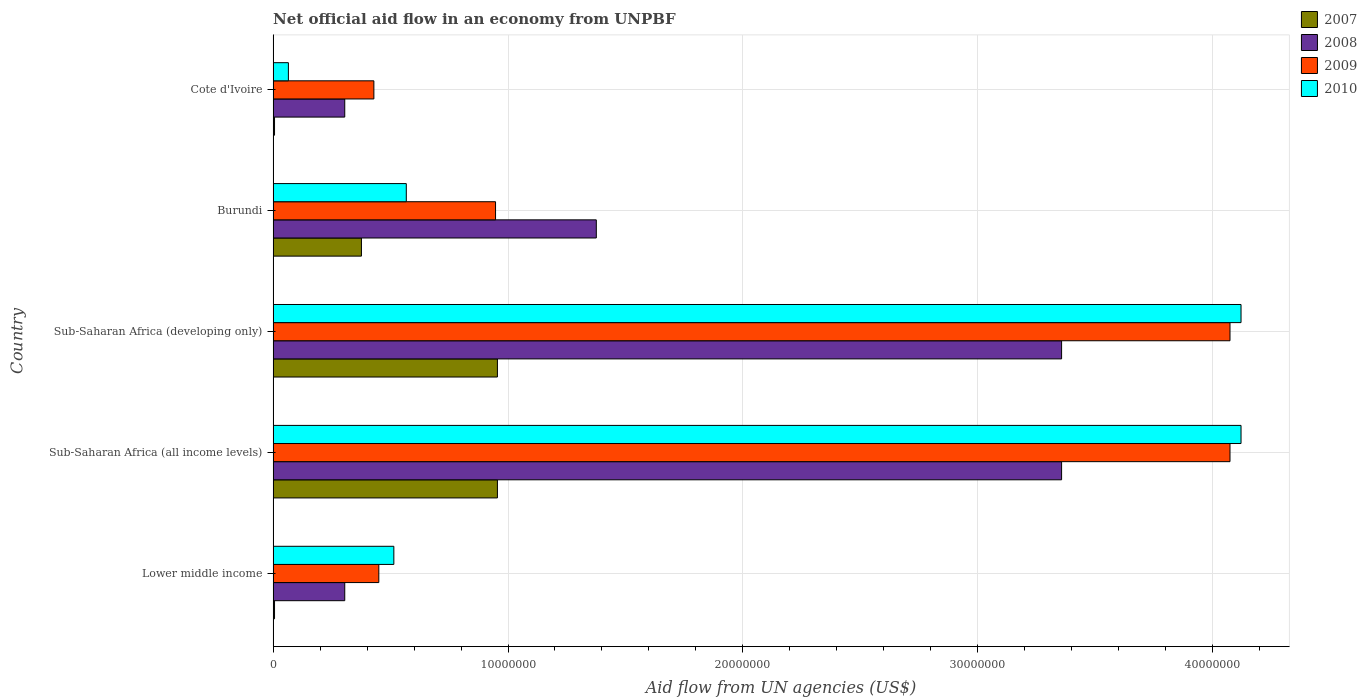How many different coloured bars are there?
Provide a succinct answer. 4. How many groups of bars are there?
Provide a succinct answer. 5. Are the number of bars per tick equal to the number of legend labels?
Keep it short and to the point. Yes. How many bars are there on the 5th tick from the bottom?
Give a very brief answer. 4. What is the label of the 3rd group of bars from the top?
Provide a short and direct response. Sub-Saharan Africa (developing only). What is the net official aid flow in 2008 in Lower middle income?
Your response must be concise. 3.05e+06. Across all countries, what is the maximum net official aid flow in 2007?
Offer a very short reply. 9.55e+06. Across all countries, what is the minimum net official aid flow in 2010?
Give a very brief answer. 6.50e+05. In which country was the net official aid flow in 2010 maximum?
Provide a short and direct response. Sub-Saharan Africa (all income levels). In which country was the net official aid flow in 2008 minimum?
Keep it short and to the point. Lower middle income. What is the total net official aid flow in 2007 in the graph?
Ensure brevity in your answer.  2.30e+07. What is the difference between the net official aid flow in 2010 in Burundi and that in Sub-Saharan Africa (developing only)?
Provide a succinct answer. -3.55e+07. What is the difference between the net official aid flow in 2008 in Sub-Saharan Africa (developing only) and the net official aid flow in 2007 in Lower middle income?
Offer a terse response. 3.35e+07. What is the average net official aid flow in 2008 per country?
Your response must be concise. 1.74e+07. What is the difference between the net official aid flow in 2009 and net official aid flow in 2010 in Sub-Saharan Africa (developing only)?
Give a very brief answer. -4.70e+05. In how many countries, is the net official aid flow in 2007 greater than 22000000 US$?
Make the answer very short. 0. Is the net official aid flow in 2007 in Cote d'Ivoire less than that in Sub-Saharan Africa (developing only)?
Ensure brevity in your answer.  Yes. What is the difference between the highest and the second highest net official aid flow in 2010?
Make the answer very short. 0. What is the difference between the highest and the lowest net official aid flow in 2007?
Your answer should be very brief. 9.49e+06. What does the 2nd bar from the bottom in Cote d'Ivoire represents?
Offer a terse response. 2008. How many countries are there in the graph?
Your answer should be compact. 5. What is the difference between two consecutive major ticks on the X-axis?
Your answer should be very brief. 1.00e+07. Are the values on the major ticks of X-axis written in scientific E-notation?
Your answer should be compact. No. Where does the legend appear in the graph?
Your answer should be compact. Top right. What is the title of the graph?
Provide a short and direct response. Net official aid flow in an economy from UNPBF. What is the label or title of the X-axis?
Provide a succinct answer. Aid flow from UN agencies (US$). What is the label or title of the Y-axis?
Offer a terse response. Country. What is the Aid flow from UN agencies (US$) in 2007 in Lower middle income?
Offer a very short reply. 6.00e+04. What is the Aid flow from UN agencies (US$) in 2008 in Lower middle income?
Provide a short and direct response. 3.05e+06. What is the Aid flow from UN agencies (US$) of 2009 in Lower middle income?
Provide a short and direct response. 4.50e+06. What is the Aid flow from UN agencies (US$) of 2010 in Lower middle income?
Give a very brief answer. 5.14e+06. What is the Aid flow from UN agencies (US$) in 2007 in Sub-Saharan Africa (all income levels)?
Make the answer very short. 9.55e+06. What is the Aid flow from UN agencies (US$) of 2008 in Sub-Saharan Africa (all income levels)?
Offer a very short reply. 3.36e+07. What is the Aid flow from UN agencies (US$) of 2009 in Sub-Saharan Africa (all income levels)?
Offer a very short reply. 4.07e+07. What is the Aid flow from UN agencies (US$) of 2010 in Sub-Saharan Africa (all income levels)?
Offer a terse response. 4.12e+07. What is the Aid flow from UN agencies (US$) of 2007 in Sub-Saharan Africa (developing only)?
Your response must be concise. 9.55e+06. What is the Aid flow from UN agencies (US$) in 2008 in Sub-Saharan Africa (developing only)?
Give a very brief answer. 3.36e+07. What is the Aid flow from UN agencies (US$) in 2009 in Sub-Saharan Africa (developing only)?
Make the answer very short. 4.07e+07. What is the Aid flow from UN agencies (US$) in 2010 in Sub-Saharan Africa (developing only)?
Your answer should be very brief. 4.12e+07. What is the Aid flow from UN agencies (US$) of 2007 in Burundi?
Provide a succinct answer. 3.76e+06. What is the Aid flow from UN agencies (US$) in 2008 in Burundi?
Offer a terse response. 1.38e+07. What is the Aid flow from UN agencies (US$) in 2009 in Burundi?
Make the answer very short. 9.47e+06. What is the Aid flow from UN agencies (US$) of 2010 in Burundi?
Provide a short and direct response. 5.67e+06. What is the Aid flow from UN agencies (US$) in 2008 in Cote d'Ivoire?
Make the answer very short. 3.05e+06. What is the Aid flow from UN agencies (US$) in 2009 in Cote d'Ivoire?
Provide a succinct answer. 4.29e+06. What is the Aid flow from UN agencies (US$) in 2010 in Cote d'Ivoire?
Give a very brief answer. 6.50e+05. Across all countries, what is the maximum Aid flow from UN agencies (US$) in 2007?
Keep it short and to the point. 9.55e+06. Across all countries, what is the maximum Aid flow from UN agencies (US$) in 2008?
Offer a terse response. 3.36e+07. Across all countries, what is the maximum Aid flow from UN agencies (US$) in 2009?
Provide a short and direct response. 4.07e+07. Across all countries, what is the maximum Aid flow from UN agencies (US$) of 2010?
Your answer should be compact. 4.12e+07. Across all countries, what is the minimum Aid flow from UN agencies (US$) in 2008?
Offer a very short reply. 3.05e+06. Across all countries, what is the minimum Aid flow from UN agencies (US$) in 2009?
Offer a very short reply. 4.29e+06. Across all countries, what is the minimum Aid flow from UN agencies (US$) in 2010?
Your answer should be compact. 6.50e+05. What is the total Aid flow from UN agencies (US$) of 2007 in the graph?
Provide a short and direct response. 2.30e+07. What is the total Aid flow from UN agencies (US$) in 2008 in the graph?
Offer a very short reply. 8.70e+07. What is the total Aid flow from UN agencies (US$) of 2009 in the graph?
Provide a short and direct response. 9.97e+07. What is the total Aid flow from UN agencies (US$) of 2010 in the graph?
Offer a terse response. 9.39e+07. What is the difference between the Aid flow from UN agencies (US$) in 2007 in Lower middle income and that in Sub-Saharan Africa (all income levels)?
Give a very brief answer. -9.49e+06. What is the difference between the Aid flow from UN agencies (US$) in 2008 in Lower middle income and that in Sub-Saharan Africa (all income levels)?
Give a very brief answer. -3.05e+07. What is the difference between the Aid flow from UN agencies (US$) of 2009 in Lower middle income and that in Sub-Saharan Africa (all income levels)?
Make the answer very short. -3.62e+07. What is the difference between the Aid flow from UN agencies (US$) of 2010 in Lower middle income and that in Sub-Saharan Africa (all income levels)?
Your response must be concise. -3.61e+07. What is the difference between the Aid flow from UN agencies (US$) in 2007 in Lower middle income and that in Sub-Saharan Africa (developing only)?
Offer a terse response. -9.49e+06. What is the difference between the Aid flow from UN agencies (US$) in 2008 in Lower middle income and that in Sub-Saharan Africa (developing only)?
Offer a terse response. -3.05e+07. What is the difference between the Aid flow from UN agencies (US$) of 2009 in Lower middle income and that in Sub-Saharan Africa (developing only)?
Ensure brevity in your answer.  -3.62e+07. What is the difference between the Aid flow from UN agencies (US$) of 2010 in Lower middle income and that in Sub-Saharan Africa (developing only)?
Provide a short and direct response. -3.61e+07. What is the difference between the Aid flow from UN agencies (US$) of 2007 in Lower middle income and that in Burundi?
Your answer should be compact. -3.70e+06. What is the difference between the Aid flow from UN agencies (US$) in 2008 in Lower middle income and that in Burundi?
Make the answer very short. -1.07e+07. What is the difference between the Aid flow from UN agencies (US$) of 2009 in Lower middle income and that in Burundi?
Provide a short and direct response. -4.97e+06. What is the difference between the Aid flow from UN agencies (US$) in 2010 in Lower middle income and that in Burundi?
Give a very brief answer. -5.30e+05. What is the difference between the Aid flow from UN agencies (US$) of 2007 in Lower middle income and that in Cote d'Ivoire?
Your answer should be very brief. 0. What is the difference between the Aid flow from UN agencies (US$) in 2008 in Lower middle income and that in Cote d'Ivoire?
Your answer should be very brief. 0. What is the difference between the Aid flow from UN agencies (US$) of 2010 in Lower middle income and that in Cote d'Ivoire?
Provide a succinct answer. 4.49e+06. What is the difference between the Aid flow from UN agencies (US$) of 2007 in Sub-Saharan Africa (all income levels) and that in Burundi?
Give a very brief answer. 5.79e+06. What is the difference between the Aid flow from UN agencies (US$) in 2008 in Sub-Saharan Africa (all income levels) and that in Burundi?
Your answer should be compact. 1.98e+07. What is the difference between the Aid flow from UN agencies (US$) of 2009 in Sub-Saharan Africa (all income levels) and that in Burundi?
Make the answer very short. 3.13e+07. What is the difference between the Aid flow from UN agencies (US$) in 2010 in Sub-Saharan Africa (all income levels) and that in Burundi?
Make the answer very short. 3.55e+07. What is the difference between the Aid flow from UN agencies (US$) of 2007 in Sub-Saharan Africa (all income levels) and that in Cote d'Ivoire?
Offer a very short reply. 9.49e+06. What is the difference between the Aid flow from UN agencies (US$) of 2008 in Sub-Saharan Africa (all income levels) and that in Cote d'Ivoire?
Provide a succinct answer. 3.05e+07. What is the difference between the Aid flow from UN agencies (US$) of 2009 in Sub-Saharan Africa (all income levels) and that in Cote d'Ivoire?
Give a very brief answer. 3.64e+07. What is the difference between the Aid flow from UN agencies (US$) of 2010 in Sub-Saharan Africa (all income levels) and that in Cote d'Ivoire?
Offer a terse response. 4.06e+07. What is the difference between the Aid flow from UN agencies (US$) of 2007 in Sub-Saharan Africa (developing only) and that in Burundi?
Offer a terse response. 5.79e+06. What is the difference between the Aid flow from UN agencies (US$) in 2008 in Sub-Saharan Africa (developing only) and that in Burundi?
Keep it short and to the point. 1.98e+07. What is the difference between the Aid flow from UN agencies (US$) of 2009 in Sub-Saharan Africa (developing only) and that in Burundi?
Keep it short and to the point. 3.13e+07. What is the difference between the Aid flow from UN agencies (US$) in 2010 in Sub-Saharan Africa (developing only) and that in Burundi?
Ensure brevity in your answer.  3.55e+07. What is the difference between the Aid flow from UN agencies (US$) in 2007 in Sub-Saharan Africa (developing only) and that in Cote d'Ivoire?
Keep it short and to the point. 9.49e+06. What is the difference between the Aid flow from UN agencies (US$) of 2008 in Sub-Saharan Africa (developing only) and that in Cote d'Ivoire?
Keep it short and to the point. 3.05e+07. What is the difference between the Aid flow from UN agencies (US$) of 2009 in Sub-Saharan Africa (developing only) and that in Cote d'Ivoire?
Make the answer very short. 3.64e+07. What is the difference between the Aid flow from UN agencies (US$) in 2010 in Sub-Saharan Africa (developing only) and that in Cote d'Ivoire?
Keep it short and to the point. 4.06e+07. What is the difference between the Aid flow from UN agencies (US$) of 2007 in Burundi and that in Cote d'Ivoire?
Your response must be concise. 3.70e+06. What is the difference between the Aid flow from UN agencies (US$) in 2008 in Burundi and that in Cote d'Ivoire?
Give a very brief answer. 1.07e+07. What is the difference between the Aid flow from UN agencies (US$) of 2009 in Burundi and that in Cote d'Ivoire?
Offer a terse response. 5.18e+06. What is the difference between the Aid flow from UN agencies (US$) of 2010 in Burundi and that in Cote d'Ivoire?
Make the answer very short. 5.02e+06. What is the difference between the Aid flow from UN agencies (US$) of 2007 in Lower middle income and the Aid flow from UN agencies (US$) of 2008 in Sub-Saharan Africa (all income levels)?
Keep it short and to the point. -3.35e+07. What is the difference between the Aid flow from UN agencies (US$) of 2007 in Lower middle income and the Aid flow from UN agencies (US$) of 2009 in Sub-Saharan Africa (all income levels)?
Ensure brevity in your answer.  -4.07e+07. What is the difference between the Aid flow from UN agencies (US$) of 2007 in Lower middle income and the Aid flow from UN agencies (US$) of 2010 in Sub-Saharan Africa (all income levels)?
Your answer should be very brief. -4.12e+07. What is the difference between the Aid flow from UN agencies (US$) of 2008 in Lower middle income and the Aid flow from UN agencies (US$) of 2009 in Sub-Saharan Africa (all income levels)?
Your answer should be very brief. -3.77e+07. What is the difference between the Aid flow from UN agencies (US$) in 2008 in Lower middle income and the Aid flow from UN agencies (US$) in 2010 in Sub-Saharan Africa (all income levels)?
Your answer should be very brief. -3.82e+07. What is the difference between the Aid flow from UN agencies (US$) in 2009 in Lower middle income and the Aid flow from UN agencies (US$) in 2010 in Sub-Saharan Africa (all income levels)?
Offer a terse response. -3.67e+07. What is the difference between the Aid flow from UN agencies (US$) of 2007 in Lower middle income and the Aid flow from UN agencies (US$) of 2008 in Sub-Saharan Africa (developing only)?
Provide a succinct answer. -3.35e+07. What is the difference between the Aid flow from UN agencies (US$) in 2007 in Lower middle income and the Aid flow from UN agencies (US$) in 2009 in Sub-Saharan Africa (developing only)?
Give a very brief answer. -4.07e+07. What is the difference between the Aid flow from UN agencies (US$) in 2007 in Lower middle income and the Aid flow from UN agencies (US$) in 2010 in Sub-Saharan Africa (developing only)?
Make the answer very short. -4.12e+07. What is the difference between the Aid flow from UN agencies (US$) of 2008 in Lower middle income and the Aid flow from UN agencies (US$) of 2009 in Sub-Saharan Africa (developing only)?
Your response must be concise. -3.77e+07. What is the difference between the Aid flow from UN agencies (US$) in 2008 in Lower middle income and the Aid flow from UN agencies (US$) in 2010 in Sub-Saharan Africa (developing only)?
Ensure brevity in your answer.  -3.82e+07. What is the difference between the Aid flow from UN agencies (US$) in 2009 in Lower middle income and the Aid flow from UN agencies (US$) in 2010 in Sub-Saharan Africa (developing only)?
Your answer should be compact. -3.67e+07. What is the difference between the Aid flow from UN agencies (US$) of 2007 in Lower middle income and the Aid flow from UN agencies (US$) of 2008 in Burundi?
Your answer should be very brief. -1.37e+07. What is the difference between the Aid flow from UN agencies (US$) of 2007 in Lower middle income and the Aid flow from UN agencies (US$) of 2009 in Burundi?
Offer a very short reply. -9.41e+06. What is the difference between the Aid flow from UN agencies (US$) in 2007 in Lower middle income and the Aid flow from UN agencies (US$) in 2010 in Burundi?
Offer a terse response. -5.61e+06. What is the difference between the Aid flow from UN agencies (US$) in 2008 in Lower middle income and the Aid flow from UN agencies (US$) in 2009 in Burundi?
Offer a terse response. -6.42e+06. What is the difference between the Aid flow from UN agencies (US$) of 2008 in Lower middle income and the Aid flow from UN agencies (US$) of 2010 in Burundi?
Make the answer very short. -2.62e+06. What is the difference between the Aid flow from UN agencies (US$) in 2009 in Lower middle income and the Aid flow from UN agencies (US$) in 2010 in Burundi?
Ensure brevity in your answer.  -1.17e+06. What is the difference between the Aid flow from UN agencies (US$) in 2007 in Lower middle income and the Aid flow from UN agencies (US$) in 2008 in Cote d'Ivoire?
Keep it short and to the point. -2.99e+06. What is the difference between the Aid flow from UN agencies (US$) in 2007 in Lower middle income and the Aid flow from UN agencies (US$) in 2009 in Cote d'Ivoire?
Provide a succinct answer. -4.23e+06. What is the difference between the Aid flow from UN agencies (US$) in 2007 in Lower middle income and the Aid flow from UN agencies (US$) in 2010 in Cote d'Ivoire?
Make the answer very short. -5.90e+05. What is the difference between the Aid flow from UN agencies (US$) of 2008 in Lower middle income and the Aid flow from UN agencies (US$) of 2009 in Cote d'Ivoire?
Offer a terse response. -1.24e+06. What is the difference between the Aid flow from UN agencies (US$) of 2008 in Lower middle income and the Aid flow from UN agencies (US$) of 2010 in Cote d'Ivoire?
Give a very brief answer. 2.40e+06. What is the difference between the Aid flow from UN agencies (US$) in 2009 in Lower middle income and the Aid flow from UN agencies (US$) in 2010 in Cote d'Ivoire?
Offer a terse response. 3.85e+06. What is the difference between the Aid flow from UN agencies (US$) in 2007 in Sub-Saharan Africa (all income levels) and the Aid flow from UN agencies (US$) in 2008 in Sub-Saharan Africa (developing only)?
Your answer should be very brief. -2.40e+07. What is the difference between the Aid flow from UN agencies (US$) in 2007 in Sub-Saharan Africa (all income levels) and the Aid flow from UN agencies (US$) in 2009 in Sub-Saharan Africa (developing only)?
Ensure brevity in your answer.  -3.12e+07. What is the difference between the Aid flow from UN agencies (US$) of 2007 in Sub-Saharan Africa (all income levels) and the Aid flow from UN agencies (US$) of 2010 in Sub-Saharan Africa (developing only)?
Your answer should be compact. -3.17e+07. What is the difference between the Aid flow from UN agencies (US$) in 2008 in Sub-Saharan Africa (all income levels) and the Aid flow from UN agencies (US$) in 2009 in Sub-Saharan Africa (developing only)?
Your response must be concise. -7.17e+06. What is the difference between the Aid flow from UN agencies (US$) of 2008 in Sub-Saharan Africa (all income levels) and the Aid flow from UN agencies (US$) of 2010 in Sub-Saharan Africa (developing only)?
Give a very brief answer. -7.64e+06. What is the difference between the Aid flow from UN agencies (US$) in 2009 in Sub-Saharan Africa (all income levels) and the Aid flow from UN agencies (US$) in 2010 in Sub-Saharan Africa (developing only)?
Make the answer very short. -4.70e+05. What is the difference between the Aid flow from UN agencies (US$) of 2007 in Sub-Saharan Africa (all income levels) and the Aid flow from UN agencies (US$) of 2008 in Burundi?
Provide a succinct answer. -4.21e+06. What is the difference between the Aid flow from UN agencies (US$) of 2007 in Sub-Saharan Africa (all income levels) and the Aid flow from UN agencies (US$) of 2010 in Burundi?
Make the answer very short. 3.88e+06. What is the difference between the Aid flow from UN agencies (US$) in 2008 in Sub-Saharan Africa (all income levels) and the Aid flow from UN agencies (US$) in 2009 in Burundi?
Your answer should be very brief. 2.41e+07. What is the difference between the Aid flow from UN agencies (US$) of 2008 in Sub-Saharan Africa (all income levels) and the Aid flow from UN agencies (US$) of 2010 in Burundi?
Keep it short and to the point. 2.79e+07. What is the difference between the Aid flow from UN agencies (US$) in 2009 in Sub-Saharan Africa (all income levels) and the Aid flow from UN agencies (US$) in 2010 in Burundi?
Ensure brevity in your answer.  3.51e+07. What is the difference between the Aid flow from UN agencies (US$) in 2007 in Sub-Saharan Africa (all income levels) and the Aid flow from UN agencies (US$) in 2008 in Cote d'Ivoire?
Provide a short and direct response. 6.50e+06. What is the difference between the Aid flow from UN agencies (US$) of 2007 in Sub-Saharan Africa (all income levels) and the Aid flow from UN agencies (US$) of 2009 in Cote d'Ivoire?
Keep it short and to the point. 5.26e+06. What is the difference between the Aid flow from UN agencies (US$) in 2007 in Sub-Saharan Africa (all income levels) and the Aid flow from UN agencies (US$) in 2010 in Cote d'Ivoire?
Offer a very short reply. 8.90e+06. What is the difference between the Aid flow from UN agencies (US$) of 2008 in Sub-Saharan Africa (all income levels) and the Aid flow from UN agencies (US$) of 2009 in Cote d'Ivoire?
Provide a short and direct response. 2.93e+07. What is the difference between the Aid flow from UN agencies (US$) in 2008 in Sub-Saharan Africa (all income levels) and the Aid flow from UN agencies (US$) in 2010 in Cote d'Ivoire?
Your answer should be very brief. 3.29e+07. What is the difference between the Aid flow from UN agencies (US$) in 2009 in Sub-Saharan Africa (all income levels) and the Aid flow from UN agencies (US$) in 2010 in Cote d'Ivoire?
Your answer should be very brief. 4.01e+07. What is the difference between the Aid flow from UN agencies (US$) in 2007 in Sub-Saharan Africa (developing only) and the Aid flow from UN agencies (US$) in 2008 in Burundi?
Ensure brevity in your answer.  -4.21e+06. What is the difference between the Aid flow from UN agencies (US$) of 2007 in Sub-Saharan Africa (developing only) and the Aid flow from UN agencies (US$) of 2010 in Burundi?
Ensure brevity in your answer.  3.88e+06. What is the difference between the Aid flow from UN agencies (US$) of 2008 in Sub-Saharan Africa (developing only) and the Aid flow from UN agencies (US$) of 2009 in Burundi?
Your answer should be compact. 2.41e+07. What is the difference between the Aid flow from UN agencies (US$) of 2008 in Sub-Saharan Africa (developing only) and the Aid flow from UN agencies (US$) of 2010 in Burundi?
Provide a short and direct response. 2.79e+07. What is the difference between the Aid flow from UN agencies (US$) of 2009 in Sub-Saharan Africa (developing only) and the Aid flow from UN agencies (US$) of 2010 in Burundi?
Provide a short and direct response. 3.51e+07. What is the difference between the Aid flow from UN agencies (US$) in 2007 in Sub-Saharan Africa (developing only) and the Aid flow from UN agencies (US$) in 2008 in Cote d'Ivoire?
Offer a very short reply. 6.50e+06. What is the difference between the Aid flow from UN agencies (US$) in 2007 in Sub-Saharan Africa (developing only) and the Aid flow from UN agencies (US$) in 2009 in Cote d'Ivoire?
Offer a terse response. 5.26e+06. What is the difference between the Aid flow from UN agencies (US$) in 2007 in Sub-Saharan Africa (developing only) and the Aid flow from UN agencies (US$) in 2010 in Cote d'Ivoire?
Offer a very short reply. 8.90e+06. What is the difference between the Aid flow from UN agencies (US$) of 2008 in Sub-Saharan Africa (developing only) and the Aid flow from UN agencies (US$) of 2009 in Cote d'Ivoire?
Offer a very short reply. 2.93e+07. What is the difference between the Aid flow from UN agencies (US$) of 2008 in Sub-Saharan Africa (developing only) and the Aid flow from UN agencies (US$) of 2010 in Cote d'Ivoire?
Your answer should be very brief. 3.29e+07. What is the difference between the Aid flow from UN agencies (US$) of 2009 in Sub-Saharan Africa (developing only) and the Aid flow from UN agencies (US$) of 2010 in Cote d'Ivoire?
Ensure brevity in your answer.  4.01e+07. What is the difference between the Aid flow from UN agencies (US$) in 2007 in Burundi and the Aid flow from UN agencies (US$) in 2008 in Cote d'Ivoire?
Offer a terse response. 7.10e+05. What is the difference between the Aid flow from UN agencies (US$) in 2007 in Burundi and the Aid flow from UN agencies (US$) in 2009 in Cote d'Ivoire?
Keep it short and to the point. -5.30e+05. What is the difference between the Aid flow from UN agencies (US$) in 2007 in Burundi and the Aid flow from UN agencies (US$) in 2010 in Cote d'Ivoire?
Ensure brevity in your answer.  3.11e+06. What is the difference between the Aid flow from UN agencies (US$) of 2008 in Burundi and the Aid flow from UN agencies (US$) of 2009 in Cote d'Ivoire?
Offer a very short reply. 9.47e+06. What is the difference between the Aid flow from UN agencies (US$) in 2008 in Burundi and the Aid flow from UN agencies (US$) in 2010 in Cote d'Ivoire?
Your answer should be compact. 1.31e+07. What is the difference between the Aid flow from UN agencies (US$) of 2009 in Burundi and the Aid flow from UN agencies (US$) of 2010 in Cote d'Ivoire?
Your answer should be very brief. 8.82e+06. What is the average Aid flow from UN agencies (US$) of 2007 per country?
Your answer should be compact. 4.60e+06. What is the average Aid flow from UN agencies (US$) of 2008 per country?
Provide a succinct answer. 1.74e+07. What is the average Aid flow from UN agencies (US$) of 2009 per country?
Your response must be concise. 1.99e+07. What is the average Aid flow from UN agencies (US$) in 2010 per country?
Give a very brief answer. 1.88e+07. What is the difference between the Aid flow from UN agencies (US$) of 2007 and Aid flow from UN agencies (US$) of 2008 in Lower middle income?
Keep it short and to the point. -2.99e+06. What is the difference between the Aid flow from UN agencies (US$) in 2007 and Aid flow from UN agencies (US$) in 2009 in Lower middle income?
Offer a very short reply. -4.44e+06. What is the difference between the Aid flow from UN agencies (US$) in 2007 and Aid flow from UN agencies (US$) in 2010 in Lower middle income?
Your response must be concise. -5.08e+06. What is the difference between the Aid flow from UN agencies (US$) in 2008 and Aid flow from UN agencies (US$) in 2009 in Lower middle income?
Your answer should be very brief. -1.45e+06. What is the difference between the Aid flow from UN agencies (US$) of 2008 and Aid flow from UN agencies (US$) of 2010 in Lower middle income?
Ensure brevity in your answer.  -2.09e+06. What is the difference between the Aid flow from UN agencies (US$) of 2009 and Aid flow from UN agencies (US$) of 2010 in Lower middle income?
Offer a terse response. -6.40e+05. What is the difference between the Aid flow from UN agencies (US$) of 2007 and Aid flow from UN agencies (US$) of 2008 in Sub-Saharan Africa (all income levels)?
Make the answer very short. -2.40e+07. What is the difference between the Aid flow from UN agencies (US$) of 2007 and Aid flow from UN agencies (US$) of 2009 in Sub-Saharan Africa (all income levels)?
Ensure brevity in your answer.  -3.12e+07. What is the difference between the Aid flow from UN agencies (US$) in 2007 and Aid flow from UN agencies (US$) in 2010 in Sub-Saharan Africa (all income levels)?
Your answer should be compact. -3.17e+07. What is the difference between the Aid flow from UN agencies (US$) in 2008 and Aid flow from UN agencies (US$) in 2009 in Sub-Saharan Africa (all income levels)?
Offer a terse response. -7.17e+06. What is the difference between the Aid flow from UN agencies (US$) of 2008 and Aid flow from UN agencies (US$) of 2010 in Sub-Saharan Africa (all income levels)?
Offer a terse response. -7.64e+06. What is the difference between the Aid flow from UN agencies (US$) in 2009 and Aid flow from UN agencies (US$) in 2010 in Sub-Saharan Africa (all income levels)?
Your response must be concise. -4.70e+05. What is the difference between the Aid flow from UN agencies (US$) of 2007 and Aid flow from UN agencies (US$) of 2008 in Sub-Saharan Africa (developing only)?
Give a very brief answer. -2.40e+07. What is the difference between the Aid flow from UN agencies (US$) of 2007 and Aid flow from UN agencies (US$) of 2009 in Sub-Saharan Africa (developing only)?
Your answer should be compact. -3.12e+07. What is the difference between the Aid flow from UN agencies (US$) of 2007 and Aid flow from UN agencies (US$) of 2010 in Sub-Saharan Africa (developing only)?
Make the answer very short. -3.17e+07. What is the difference between the Aid flow from UN agencies (US$) in 2008 and Aid flow from UN agencies (US$) in 2009 in Sub-Saharan Africa (developing only)?
Offer a very short reply. -7.17e+06. What is the difference between the Aid flow from UN agencies (US$) in 2008 and Aid flow from UN agencies (US$) in 2010 in Sub-Saharan Africa (developing only)?
Ensure brevity in your answer.  -7.64e+06. What is the difference between the Aid flow from UN agencies (US$) in 2009 and Aid flow from UN agencies (US$) in 2010 in Sub-Saharan Africa (developing only)?
Your answer should be compact. -4.70e+05. What is the difference between the Aid flow from UN agencies (US$) in 2007 and Aid flow from UN agencies (US$) in 2008 in Burundi?
Provide a succinct answer. -1.00e+07. What is the difference between the Aid flow from UN agencies (US$) of 2007 and Aid flow from UN agencies (US$) of 2009 in Burundi?
Provide a short and direct response. -5.71e+06. What is the difference between the Aid flow from UN agencies (US$) of 2007 and Aid flow from UN agencies (US$) of 2010 in Burundi?
Your answer should be compact. -1.91e+06. What is the difference between the Aid flow from UN agencies (US$) in 2008 and Aid flow from UN agencies (US$) in 2009 in Burundi?
Provide a short and direct response. 4.29e+06. What is the difference between the Aid flow from UN agencies (US$) in 2008 and Aid flow from UN agencies (US$) in 2010 in Burundi?
Keep it short and to the point. 8.09e+06. What is the difference between the Aid flow from UN agencies (US$) in 2009 and Aid flow from UN agencies (US$) in 2010 in Burundi?
Give a very brief answer. 3.80e+06. What is the difference between the Aid flow from UN agencies (US$) in 2007 and Aid flow from UN agencies (US$) in 2008 in Cote d'Ivoire?
Ensure brevity in your answer.  -2.99e+06. What is the difference between the Aid flow from UN agencies (US$) of 2007 and Aid flow from UN agencies (US$) of 2009 in Cote d'Ivoire?
Make the answer very short. -4.23e+06. What is the difference between the Aid flow from UN agencies (US$) of 2007 and Aid flow from UN agencies (US$) of 2010 in Cote d'Ivoire?
Provide a short and direct response. -5.90e+05. What is the difference between the Aid flow from UN agencies (US$) in 2008 and Aid flow from UN agencies (US$) in 2009 in Cote d'Ivoire?
Offer a terse response. -1.24e+06. What is the difference between the Aid flow from UN agencies (US$) in 2008 and Aid flow from UN agencies (US$) in 2010 in Cote d'Ivoire?
Ensure brevity in your answer.  2.40e+06. What is the difference between the Aid flow from UN agencies (US$) in 2009 and Aid flow from UN agencies (US$) in 2010 in Cote d'Ivoire?
Keep it short and to the point. 3.64e+06. What is the ratio of the Aid flow from UN agencies (US$) in 2007 in Lower middle income to that in Sub-Saharan Africa (all income levels)?
Ensure brevity in your answer.  0.01. What is the ratio of the Aid flow from UN agencies (US$) in 2008 in Lower middle income to that in Sub-Saharan Africa (all income levels)?
Your response must be concise. 0.09. What is the ratio of the Aid flow from UN agencies (US$) of 2009 in Lower middle income to that in Sub-Saharan Africa (all income levels)?
Your answer should be very brief. 0.11. What is the ratio of the Aid flow from UN agencies (US$) of 2010 in Lower middle income to that in Sub-Saharan Africa (all income levels)?
Ensure brevity in your answer.  0.12. What is the ratio of the Aid flow from UN agencies (US$) of 2007 in Lower middle income to that in Sub-Saharan Africa (developing only)?
Ensure brevity in your answer.  0.01. What is the ratio of the Aid flow from UN agencies (US$) in 2008 in Lower middle income to that in Sub-Saharan Africa (developing only)?
Make the answer very short. 0.09. What is the ratio of the Aid flow from UN agencies (US$) of 2009 in Lower middle income to that in Sub-Saharan Africa (developing only)?
Your answer should be very brief. 0.11. What is the ratio of the Aid flow from UN agencies (US$) of 2010 in Lower middle income to that in Sub-Saharan Africa (developing only)?
Give a very brief answer. 0.12. What is the ratio of the Aid flow from UN agencies (US$) in 2007 in Lower middle income to that in Burundi?
Keep it short and to the point. 0.02. What is the ratio of the Aid flow from UN agencies (US$) of 2008 in Lower middle income to that in Burundi?
Your response must be concise. 0.22. What is the ratio of the Aid flow from UN agencies (US$) of 2009 in Lower middle income to that in Burundi?
Give a very brief answer. 0.48. What is the ratio of the Aid flow from UN agencies (US$) of 2010 in Lower middle income to that in Burundi?
Give a very brief answer. 0.91. What is the ratio of the Aid flow from UN agencies (US$) in 2008 in Lower middle income to that in Cote d'Ivoire?
Your response must be concise. 1. What is the ratio of the Aid flow from UN agencies (US$) in 2009 in Lower middle income to that in Cote d'Ivoire?
Make the answer very short. 1.05. What is the ratio of the Aid flow from UN agencies (US$) of 2010 in Lower middle income to that in Cote d'Ivoire?
Provide a succinct answer. 7.91. What is the ratio of the Aid flow from UN agencies (US$) of 2008 in Sub-Saharan Africa (all income levels) to that in Sub-Saharan Africa (developing only)?
Offer a terse response. 1. What is the ratio of the Aid flow from UN agencies (US$) of 2010 in Sub-Saharan Africa (all income levels) to that in Sub-Saharan Africa (developing only)?
Provide a succinct answer. 1. What is the ratio of the Aid flow from UN agencies (US$) in 2007 in Sub-Saharan Africa (all income levels) to that in Burundi?
Ensure brevity in your answer.  2.54. What is the ratio of the Aid flow from UN agencies (US$) in 2008 in Sub-Saharan Africa (all income levels) to that in Burundi?
Provide a short and direct response. 2.44. What is the ratio of the Aid flow from UN agencies (US$) in 2009 in Sub-Saharan Africa (all income levels) to that in Burundi?
Your answer should be compact. 4.3. What is the ratio of the Aid flow from UN agencies (US$) in 2010 in Sub-Saharan Africa (all income levels) to that in Burundi?
Offer a terse response. 7.27. What is the ratio of the Aid flow from UN agencies (US$) of 2007 in Sub-Saharan Africa (all income levels) to that in Cote d'Ivoire?
Give a very brief answer. 159.17. What is the ratio of the Aid flow from UN agencies (US$) in 2008 in Sub-Saharan Africa (all income levels) to that in Cote d'Ivoire?
Provide a succinct answer. 11.01. What is the ratio of the Aid flow from UN agencies (US$) in 2009 in Sub-Saharan Africa (all income levels) to that in Cote d'Ivoire?
Give a very brief answer. 9.5. What is the ratio of the Aid flow from UN agencies (US$) of 2010 in Sub-Saharan Africa (all income levels) to that in Cote d'Ivoire?
Offer a very short reply. 63.4. What is the ratio of the Aid flow from UN agencies (US$) in 2007 in Sub-Saharan Africa (developing only) to that in Burundi?
Ensure brevity in your answer.  2.54. What is the ratio of the Aid flow from UN agencies (US$) in 2008 in Sub-Saharan Africa (developing only) to that in Burundi?
Your answer should be very brief. 2.44. What is the ratio of the Aid flow from UN agencies (US$) in 2009 in Sub-Saharan Africa (developing only) to that in Burundi?
Your answer should be compact. 4.3. What is the ratio of the Aid flow from UN agencies (US$) in 2010 in Sub-Saharan Africa (developing only) to that in Burundi?
Your answer should be very brief. 7.27. What is the ratio of the Aid flow from UN agencies (US$) in 2007 in Sub-Saharan Africa (developing only) to that in Cote d'Ivoire?
Provide a short and direct response. 159.17. What is the ratio of the Aid flow from UN agencies (US$) of 2008 in Sub-Saharan Africa (developing only) to that in Cote d'Ivoire?
Your answer should be very brief. 11.01. What is the ratio of the Aid flow from UN agencies (US$) of 2009 in Sub-Saharan Africa (developing only) to that in Cote d'Ivoire?
Offer a terse response. 9.5. What is the ratio of the Aid flow from UN agencies (US$) of 2010 in Sub-Saharan Africa (developing only) to that in Cote d'Ivoire?
Provide a short and direct response. 63.4. What is the ratio of the Aid flow from UN agencies (US$) in 2007 in Burundi to that in Cote d'Ivoire?
Give a very brief answer. 62.67. What is the ratio of the Aid flow from UN agencies (US$) of 2008 in Burundi to that in Cote d'Ivoire?
Give a very brief answer. 4.51. What is the ratio of the Aid flow from UN agencies (US$) in 2009 in Burundi to that in Cote d'Ivoire?
Your response must be concise. 2.21. What is the ratio of the Aid flow from UN agencies (US$) of 2010 in Burundi to that in Cote d'Ivoire?
Your answer should be very brief. 8.72. What is the difference between the highest and the second highest Aid flow from UN agencies (US$) in 2007?
Your answer should be very brief. 0. What is the difference between the highest and the second highest Aid flow from UN agencies (US$) in 2008?
Keep it short and to the point. 0. What is the difference between the highest and the second highest Aid flow from UN agencies (US$) in 2009?
Your answer should be compact. 0. What is the difference between the highest and the lowest Aid flow from UN agencies (US$) of 2007?
Offer a very short reply. 9.49e+06. What is the difference between the highest and the lowest Aid flow from UN agencies (US$) in 2008?
Ensure brevity in your answer.  3.05e+07. What is the difference between the highest and the lowest Aid flow from UN agencies (US$) of 2009?
Your answer should be very brief. 3.64e+07. What is the difference between the highest and the lowest Aid flow from UN agencies (US$) of 2010?
Ensure brevity in your answer.  4.06e+07. 